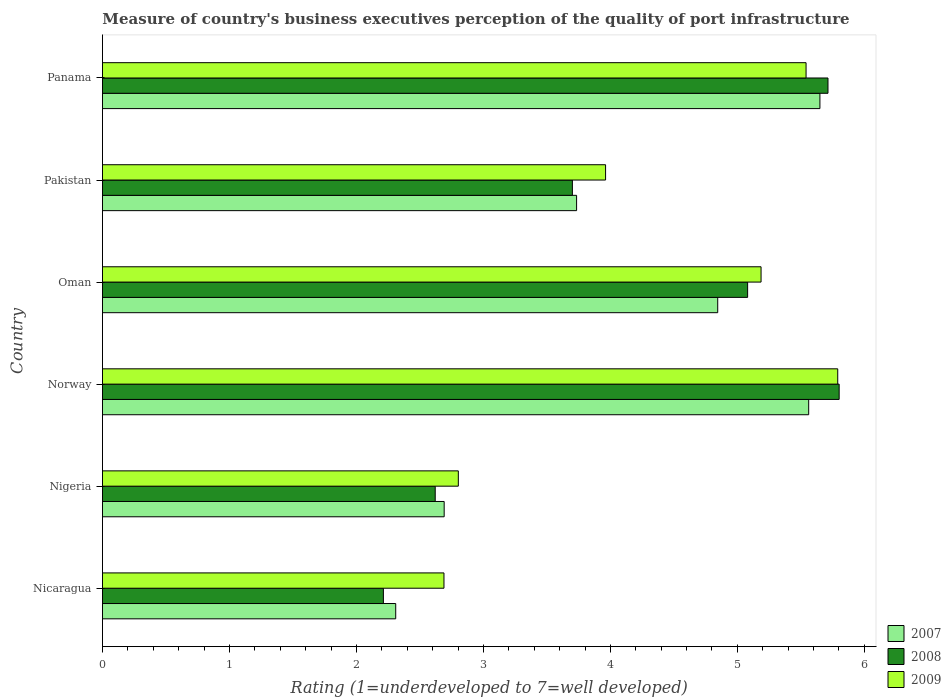How many different coloured bars are there?
Provide a short and direct response. 3. How many groups of bars are there?
Give a very brief answer. 6. Are the number of bars per tick equal to the number of legend labels?
Offer a terse response. Yes. Are the number of bars on each tick of the Y-axis equal?
Your answer should be compact. Yes. What is the label of the 2nd group of bars from the top?
Provide a succinct answer. Pakistan. In how many cases, is the number of bars for a given country not equal to the number of legend labels?
Provide a short and direct response. 0. What is the ratings of the quality of port infrastructure in 2009 in Nicaragua?
Ensure brevity in your answer.  2.69. Across all countries, what is the maximum ratings of the quality of port infrastructure in 2007?
Offer a very short reply. 5.65. Across all countries, what is the minimum ratings of the quality of port infrastructure in 2009?
Ensure brevity in your answer.  2.69. In which country was the ratings of the quality of port infrastructure in 2008 maximum?
Provide a succinct answer. Norway. In which country was the ratings of the quality of port infrastructure in 2008 minimum?
Provide a succinct answer. Nicaragua. What is the total ratings of the quality of port infrastructure in 2009 in the graph?
Your answer should be very brief. 25.97. What is the difference between the ratings of the quality of port infrastructure in 2008 in Nigeria and that in Oman?
Make the answer very short. -2.46. What is the difference between the ratings of the quality of port infrastructure in 2008 in Norway and the ratings of the quality of port infrastructure in 2007 in Oman?
Your response must be concise. 0.96. What is the average ratings of the quality of port infrastructure in 2007 per country?
Offer a very short reply. 4.13. What is the difference between the ratings of the quality of port infrastructure in 2008 and ratings of the quality of port infrastructure in 2007 in Pakistan?
Keep it short and to the point. -0.03. What is the ratio of the ratings of the quality of port infrastructure in 2008 in Pakistan to that in Panama?
Your answer should be very brief. 0.65. What is the difference between the highest and the second highest ratings of the quality of port infrastructure in 2008?
Provide a succinct answer. 0.09. What is the difference between the highest and the lowest ratings of the quality of port infrastructure in 2007?
Provide a succinct answer. 3.34. What does the 3rd bar from the bottom in Oman represents?
Your response must be concise. 2009. Is it the case that in every country, the sum of the ratings of the quality of port infrastructure in 2009 and ratings of the quality of port infrastructure in 2007 is greater than the ratings of the quality of port infrastructure in 2008?
Offer a very short reply. Yes. How many bars are there?
Give a very brief answer. 18. How many legend labels are there?
Offer a very short reply. 3. What is the title of the graph?
Your response must be concise. Measure of country's business executives perception of the quality of port infrastructure. What is the label or title of the X-axis?
Your answer should be very brief. Rating (1=underdeveloped to 7=well developed). What is the Rating (1=underdeveloped to 7=well developed) in 2007 in Nicaragua?
Keep it short and to the point. 2.31. What is the Rating (1=underdeveloped to 7=well developed) in 2008 in Nicaragua?
Your response must be concise. 2.21. What is the Rating (1=underdeveloped to 7=well developed) of 2009 in Nicaragua?
Your answer should be very brief. 2.69. What is the Rating (1=underdeveloped to 7=well developed) of 2007 in Nigeria?
Offer a terse response. 2.69. What is the Rating (1=underdeveloped to 7=well developed) in 2008 in Nigeria?
Keep it short and to the point. 2.62. What is the Rating (1=underdeveloped to 7=well developed) of 2009 in Nigeria?
Give a very brief answer. 2.8. What is the Rating (1=underdeveloped to 7=well developed) of 2007 in Norway?
Provide a short and direct response. 5.56. What is the Rating (1=underdeveloped to 7=well developed) in 2008 in Norway?
Make the answer very short. 5.8. What is the Rating (1=underdeveloped to 7=well developed) of 2009 in Norway?
Offer a very short reply. 5.79. What is the Rating (1=underdeveloped to 7=well developed) in 2007 in Oman?
Your answer should be compact. 4.85. What is the Rating (1=underdeveloped to 7=well developed) of 2008 in Oman?
Your answer should be very brief. 5.08. What is the Rating (1=underdeveloped to 7=well developed) in 2009 in Oman?
Your response must be concise. 5.19. What is the Rating (1=underdeveloped to 7=well developed) of 2007 in Pakistan?
Your answer should be compact. 3.73. What is the Rating (1=underdeveloped to 7=well developed) of 2008 in Pakistan?
Offer a terse response. 3.7. What is the Rating (1=underdeveloped to 7=well developed) of 2009 in Pakistan?
Your response must be concise. 3.96. What is the Rating (1=underdeveloped to 7=well developed) in 2007 in Panama?
Offer a terse response. 5.65. What is the Rating (1=underdeveloped to 7=well developed) of 2008 in Panama?
Keep it short and to the point. 5.71. What is the Rating (1=underdeveloped to 7=well developed) in 2009 in Panama?
Keep it short and to the point. 5.54. Across all countries, what is the maximum Rating (1=underdeveloped to 7=well developed) in 2007?
Keep it short and to the point. 5.65. Across all countries, what is the maximum Rating (1=underdeveloped to 7=well developed) of 2008?
Provide a short and direct response. 5.8. Across all countries, what is the maximum Rating (1=underdeveloped to 7=well developed) in 2009?
Offer a very short reply. 5.79. Across all countries, what is the minimum Rating (1=underdeveloped to 7=well developed) of 2007?
Your answer should be compact. 2.31. Across all countries, what is the minimum Rating (1=underdeveloped to 7=well developed) of 2008?
Your answer should be compact. 2.21. Across all countries, what is the minimum Rating (1=underdeveloped to 7=well developed) of 2009?
Offer a terse response. 2.69. What is the total Rating (1=underdeveloped to 7=well developed) in 2007 in the graph?
Ensure brevity in your answer.  24.79. What is the total Rating (1=underdeveloped to 7=well developed) of 2008 in the graph?
Give a very brief answer. 25.13. What is the total Rating (1=underdeveloped to 7=well developed) of 2009 in the graph?
Provide a short and direct response. 25.97. What is the difference between the Rating (1=underdeveloped to 7=well developed) in 2007 in Nicaragua and that in Nigeria?
Provide a short and direct response. -0.38. What is the difference between the Rating (1=underdeveloped to 7=well developed) in 2008 in Nicaragua and that in Nigeria?
Offer a very short reply. -0.41. What is the difference between the Rating (1=underdeveloped to 7=well developed) of 2009 in Nicaragua and that in Nigeria?
Your answer should be compact. -0.11. What is the difference between the Rating (1=underdeveloped to 7=well developed) of 2007 in Nicaragua and that in Norway?
Offer a very short reply. -3.25. What is the difference between the Rating (1=underdeveloped to 7=well developed) in 2008 in Nicaragua and that in Norway?
Offer a very short reply. -3.59. What is the difference between the Rating (1=underdeveloped to 7=well developed) of 2009 in Nicaragua and that in Norway?
Ensure brevity in your answer.  -3.1. What is the difference between the Rating (1=underdeveloped to 7=well developed) of 2007 in Nicaragua and that in Oman?
Your response must be concise. -2.54. What is the difference between the Rating (1=underdeveloped to 7=well developed) of 2008 in Nicaragua and that in Oman?
Keep it short and to the point. -2.87. What is the difference between the Rating (1=underdeveloped to 7=well developed) in 2009 in Nicaragua and that in Oman?
Keep it short and to the point. -2.5. What is the difference between the Rating (1=underdeveloped to 7=well developed) of 2007 in Nicaragua and that in Pakistan?
Your answer should be compact. -1.42. What is the difference between the Rating (1=underdeveloped to 7=well developed) of 2008 in Nicaragua and that in Pakistan?
Offer a terse response. -1.49. What is the difference between the Rating (1=underdeveloped to 7=well developed) in 2009 in Nicaragua and that in Pakistan?
Make the answer very short. -1.27. What is the difference between the Rating (1=underdeveloped to 7=well developed) in 2007 in Nicaragua and that in Panama?
Your response must be concise. -3.34. What is the difference between the Rating (1=underdeveloped to 7=well developed) in 2008 in Nicaragua and that in Panama?
Give a very brief answer. -3.5. What is the difference between the Rating (1=underdeveloped to 7=well developed) in 2009 in Nicaragua and that in Panama?
Give a very brief answer. -2.85. What is the difference between the Rating (1=underdeveloped to 7=well developed) of 2007 in Nigeria and that in Norway?
Give a very brief answer. -2.87. What is the difference between the Rating (1=underdeveloped to 7=well developed) of 2008 in Nigeria and that in Norway?
Provide a succinct answer. -3.18. What is the difference between the Rating (1=underdeveloped to 7=well developed) in 2009 in Nigeria and that in Norway?
Keep it short and to the point. -2.99. What is the difference between the Rating (1=underdeveloped to 7=well developed) of 2007 in Nigeria and that in Oman?
Your answer should be very brief. -2.15. What is the difference between the Rating (1=underdeveloped to 7=well developed) in 2008 in Nigeria and that in Oman?
Offer a terse response. -2.46. What is the difference between the Rating (1=underdeveloped to 7=well developed) in 2009 in Nigeria and that in Oman?
Your answer should be compact. -2.38. What is the difference between the Rating (1=underdeveloped to 7=well developed) of 2007 in Nigeria and that in Pakistan?
Provide a succinct answer. -1.04. What is the difference between the Rating (1=underdeveloped to 7=well developed) in 2008 in Nigeria and that in Pakistan?
Provide a short and direct response. -1.08. What is the difference between the Rating (1=underdeveloped to 7=well developed) in 2009 in Nigeria and that in Pakistan?
Make the answer very short. -1.16. What is the difference between the Rating (1=underdeveloped to 7=well developed) of 2007 in Nigeria and that in Panama?
Your answer should be very brief. -2.96. What is the difference between the Rating (1=underdeveloped to 7=well developed) in 2008 in Nigeria and that in Panama?
Your answer should be compact. -3.09. What is the difference between the Rating (1=underdeveloped to 7=well developed) in 2009 in Nigeria and that in Panama?
Offer a terse response. -2.74. What is the difference between the Rating (1=underdeveloped to 7=well developed) of 2007 in Norway and that in Oman?
Give a very brief answer. 0.72. What is the difference between the Rating (1=underdeveloped to 7=well developed) in 2008 in Norway and that in Oman?
Your answer should be compact. 0.72. What is the difference between the Rating (1=underdeveloped to 7=well developed) in 2009 in Norway and that in Oman?
Your answer should be very brief. 0.6. What is the difference between the Rating (1=underdeveloped to 7=well developed) of 2007 in Norway and that in Pakistan?
Ensure brevity in your answer.  1.83. What is the difference between the Rating (1=underdeveloped to 7=well developed) of 2008 in Norway and that in Pakistan?
Your answer should be very brief. 2.1. What is the difference between the Rating (1=underdeveloped to 7=well developed) of 2009 in Norway and that in Pakistan?
Ensure brevity in your answer.  1.83. What is the difference between the Rating (1=underdeveloped to 7=well developed) in 2007 in Norway and that in Panama?
Give a very brief answer. -0.09. What is the difference between the Rating (1=underdeveloped to 7=well developed) in 2008 in Norway and that in Panama?
Offer a terse response. 0.09. What is the difference between the Rating (1=underdeveloped to 7=well developed) in 2009 in Norway and that in Panama?
Offer a very short reply. 0.25. What is the difference between the Rating (1=underdeveloped to 7=well developed) in 2007 in Oman and that in Pakistan?
Give a very brief answer. 1.11. What is the difference between the Rating (1=underdeveloped to 7=well developed) in 2008 in Oman and that in Pakistan?
Ensure brevity in your answer.  1.38. What is the difference between the Rating (1=underdeveloped to 7=well developed) in 2009 in Oman and that in Pakistan?
Ensure brevity in your answer.  1.22. What is the difference between the Rating (1=underdeveloped to 7=well developed) in 2007 in Oman and that in Panama?
Keep it short and to the point. -0.8. What is the difference between the Rating (1=underdeveloped to 7=well developed) in 2008 in Oman and that in Panama?
Ensure brevity in your answer.  -0.63. What is the difference between the Rating (1=underdeveloped to 7=well developed) of 2009 in Oman and that in Panama?
Give a very brief answer. -0.35. What is the difference between the Rating (1=underdeveloped to 7=well developed) of 2007 in Pakistan and that in Panama?
Make the answer very short. -1.92. What is the difference between the Rating (1=underdeveloped to 7=well developed) in 2008 in Pakistan and that in Panama?
Give a very brief answer. -2.01. What is the difference between the Rating (1=underdeveloped to 7=well developed) of 2009 in Pakistan and that in Panama?
Offer a terse response. -1.58. What is the difference between the Rating (1=underdeveloped to 7=well developed) in 2007 in Nicaragua and the Rating (1=underdeveloped to 7=well developed) in 2008 in Nigeria?
Provide a succinct answer. -0.31. What is the difference between the Rating (1=underdeveloped to 7=well developed) of 2007 in Nicaragua and the Rating (1=underdeveloped to 7=well developed) of 2009 in Nigeria?
Provide a short and direct response. -0.49. What is the difference between the Rating (1=underdeveloped to 7=well developed) in 2008 in Nicaragua and the Rating (1=underdeveloped to 7=well developed) in 2009 in Nigeria?
Provide a short and direct response. -0.59. What is the difference between the Rating (1=underdeveloped to 7=well developed) in 2007 in Nicaragua and the Rating (1=underdeveloped to 7=well developed) in 2008 in Norway?
Offer a terse response. -3.49. What is the difference between the Rating (1=underdeveloped to 7=well developed) of 2007 in Nicaragua and the Rating (1=underdeveloped to 7=well developed) of 2009 in Norway?
Ensure brevity in your answer.  -3.48. What is the difference between the Rating (1=underdeveloped to 7=well developed) in 2008 in Nicaragua and the Rating (1=underdeveloped to 7=well developed) in 2009 in Norway?
Provide a succinct answer. -3.58. What is the difference between the Rating (1=underdeveloped to 7=well developed) of 2007 in Nicaragua and the Rating (1=underdeveloped to 7=well developed) of 2008 in Oman?
Give a very brief answer. -2.77. What is the difference between the Rating (1=underdeveloped to 7=well developed) in 2007 in Nicaragua and the Rating (1=underdeveloped to 7=well developed) in 2009 in Oman?
Your answer should be very brief. -2.88. What is the difference between the Rating (1=underdeveloped to 7=well developed) of 2008 in Nicaragua and the Rating (1=underdeveloped to 7=well developed) of 2009 in Oman?
Offer a very short reply. -2.97. What is the difference between the Rating (1=underdeveloped to 7=well developed) of 2007 in Nicaragua and the Rating (1=underdeveloped to 7=well developed) of 2008 in Pakistan?
Keep it short and to the point. -1.39. What is the difference between the Rating (1=underdeveloped to 7=well developed) of 2007 in Nicaragua and the Rating (1=underdeveloped to 7=well developed) of 2009 in Pakistan?
Ensure brevity in your answer.  -1.65. What is the difference between the Rating (1=underdeveloped to 7=well developed) in 2008 in Nicaragua and the Rating (1=underdeveloped to 7=well developed) in 2009 in Pakistan?
Make the answer very short. -1.75. What is the difference between the Rating (1=underdeveloped to 7=well developed) in 2007 in Nicaragua and the Rating (1=underdeveloped to 7=well developed) in 2008 in Panama?
Your answer should be very brief. -3.4. What is the difference between the Rating (1=underdeveloped to 7=well developed) in 2007 in Nicaragua and the Rating (1=underdeveloped to 7=well developed) in 2009 in Panama?
Provide a short and direct response. -3.23. What is the difference between the Rating (1=underdeveloped to 7=well developed) in 2008 in Nicaragua and the Rating (1=underdeveloped to 7=well developed) in 2009 in Panama?
Your response must be concise. -3.33. What is the difference between the Rating (1=underdeveloped to 7=well developed) in 2007 in Nigeria and the Rating (1=underdeveloped to 7=well developed) in 2008 in Norway?
Offer a terse response. -3.11. What is the difference between the Rating (1=underdeveloped to 7=well developed) in 2007 in Nigeria and the Rating (1=underdeveloped to 7=well developed) in 2009 in Norway?
Ensure brevity in your answer.  -3.1. What is the difference between the Rating (1=underdeveloped to 7=well developed) of 2008 in Nigeria and the Rating (1=underdeveloped to 7=well developed) of 2009 in Norway?
Offer a terse response. -3.17. What is the difference between the Rating (1=underdeveloped to 7=well developed) of 2007 in Nigeria and the Rating (1=underdeveloped to 7=well developed) of 2008 in Oman?
Make the answer very short. -2.39. What is the difference between the Rating (1=underdeveloped to 7=well developed) of 2007 in Nigeria and the Rating (1=underdeveloped to 7=well developed) of 2009 in Oman?
Offer a terse response. -2.5. What is the difference between the Rating (1=underdeveloped to 7=well developed) in 2008 in Nigeria and the Rating (1=underdeveloped to 7=well developed) in 2009 in Oman?
Keep it short and to the point. -2.57. What is the difference between the Rating (1=underdeveloped to 7=well developed) in 2007 in Nigeria and the Rating (1=underdeveloped to 7=well developed) in 2008 in Pakistan?
Give a very brief answer. -1.01. What is the difference between the Rating (1=underdeveloped to 7=well developed) in 2007 in Nigeria and the Rating (1=underdeveloped to 7=well developed) in 2009 in Pakistan?
Provide a succinct answer. -1.27. What is the difference between the Rating (1=underdeveloped to 7=well developed) of 2008 in Nigeria and the Rating (1=underdeveloped to 7=well developed) of 2009 in Pakistan?
Offer a very short reply. -1.34. What is the difference between the Rating (1=underdeveloped to 7=well developed) of 2007 in Nigeria and the Rating (1=underdeveloped to 7=well developed) of 2008 in Panama?
Your answer should be very brief. -3.02. What is the difference between the Rating (1=underdeveloped to 7=well developed) in 2007 in Nigeria and the Rating (1=underdeveloped to 7=well developed) in 2009 in Panama?
Give a very brief answer. -2.85. What is the difference between the Rating (1=underdeveloped to 7=well developed) in 2008 in Nigeria and the Rating (1=underdeveloped to 7=well developed) in 2009 in Panama?
Provide a short and direct response. -2.92. What is the difference between the Rating (1=underdeveloped to 7=well developed) of 2007 in Norway and the Rating (1=underdeveloped to 7=well developed) of 2008 in Oman?
Give a very brief answer. 0.48. What is the difference between the Rating (1=underdeveloped to 7=well developed) of 2007 in Norway and the Rating (1=underdeveloped to 7=well developed) of 2009 in Oman?
Make the answer very short. 0.38. What is the difference between the Rating (1=underdeveloped to 7=well developed) of 2008 in Norway and the Rating (1=underdeveloped to 7=well developed) of 2009 in Oman?
Keep it short and to the point. 0.62. What is the difference between the Rating (1=underdeveloped to 7=well developed) of 2007 in Norway and the Rating (1=underdeveloped to 7=well developed) of 2008 in Pakistan?
Your answer should be compact. 1.86. What is the difference between the Rating (1=underdeveloped to 7=well developed) of 2007 in Norway and the Rating (1=underdeveloped to 7=well developed) of 2009 in Pakistan?
Your answer should be very brief. 1.6. What is the difference between the Rating (1=underdeveloped to 7=well developed) in 2008 in Norway and the Rating (1=underdeveloped to 7=well developed) in 2009 in Pakistan?
Your answer should be compact. 1.84. What is the difference between the Rating (1=underdeveloped to 7=well developed) of 2007 in Norway and the Rating (1=underdeveloped to 7=well developed) of 2008 in Panama?
Your answer should be very brief. -0.15. What is the difference between the Rating (1=underdeveloped to 7=well developed) in 2007 in Norway and the Rating (1=underdeveloped to 7=well developed) in 2009 in Panama?
Give a very brief answer. 0.02. What is the difference between the Rating (1=underdeveloped to 7=well developed) in 2008 in Norway and the Rating (1=underdeveloped to 7=well developed) in 2009 in Panama?
Your answer should be compact. 0.26. What is the difference between the Rating (1=underdeveloped to 7=well developed) of 2007 in Oman and the Rating (1=underdeveloped to 7=well developed) of 2008 in Pakistan?
Make the answer very short. 1.14. What is the difference between the Rating (1=underdeveloped to 7=well developed) of 2007 in Oman and the Rating (1=underdeveloped to 7=well developed) of 2009 in Pakistan?
Ensure brevity in your answer.  0.88. What is the difference between the Rating (1=underdeveloped to 7=well developed) in 2008 in Oman and the Rating (1=underdeveloped to 7=well developed) in 2009 in Pakistan?
Keep it short and to the point. 1.12. What is the difference between the Rating (1=underdeveloped to 7=well developed) in 2007 in Oman and the Rating (1=underdeveloped to 7=well developed) in 2008 in Panama?
Provide a short and direct response. -0.87. What is the difference between the Rating (1=underdeveloped to 7=well developed) of 2007 in Oman and the Rating (1=underdeveloped to 7=well developed) of 2009 in Panama?
Ensure brevity in your answer.  -0.7. What is the difference between the Rating (1=underdeveloped to 7=well developed) of 2008 in Oman and the Rating (1=underdeveloped to 7=well developed) of 2009 in Panama?
Your answer should be very brief. -0.46. What is the difference between the Rating (1=underdeveloped to 7=well developed) in 2007 in Pakistan and the Rating (1=underdeveloped to 7=well developed) in 2008 in Panama?
Provide a short and direct response. -1.98. What is the difference between the Rating (1=underdeveloped to 7=well developed) of 2007 in Pakistan and the Rating (1=underdeveloped to 7=well developed) of 2009 in Panama?
Offer a terse response. -1.81. What is the difference between the Rating (1=underdeveloped to 7=well developed) in 2008 in Pakistan and the Rating (1=underdeveloped to 7=well developed) in 2009 in Panama?
Offer a very short reply. -1.84. What is the average Rating (1=underdeveloped to 7=well developed) in 2007 per country?
Make the answer very short. 4.13. What is the average Rating (1=underdeveloped to 7=well developed) in 2008 per country?
Provide a short and direct response. 4.19. What is the average Rating (1=underdeveloped to 7=well developed) of 2009 per country?
Provide a succinct answer. 4.33. What is the difference between the Rating (1=underdeveloped to 7=well developed) in 2007 and Rating (1=underdeveloped to 7=well developed) in 2008 in Nicaragua?
Offer a terse response. 0.1. What is the difference between the Rating (1=underdeveloped to 7=well developed) in 2007 and Rating (1=underdeveloped to 7=well developed) in 2009 in Nicaragua?
Provide a short and direct response. -0.38. What is the difference between the Rating (1=underdeveloped to 7=well developed) in 2008 and Rating (1=underdeveloped to 7=well developed) in 2009 in Nicaragua?
Ensure brevity in your answer.  -0.48. What is the difference between the Rating (1=underdeveloped to 7=well developed) of 2007 and Rating (1=underdeveloped to 7=well developed) of 2008 in Nigeria?
Your answer should be compact. 0.07. What is the difference between the Rating (1=underdeveloped to 7=well developed) in 2007 and Rating (1=underdeveloped to 7=well developed) in 2009 in Nigeria?
Give a very brief answer. -0.11. What is the difference between the Rating (1=underdeveloped to 7=well developed) in 2008 and Rating (1=underdeveloped to 7=well developed) in 2009 in Nigeria?
Your answer should be very brief. -0.18. What is the difference between the Rating (1=underdeveloped to 7=well developed) of 2007 and Rating (1=underdeveloped to 7=well developed) of 2008 in Norway?
Make the answer very short. -0.24. What is the difference between the Rating (1=underdeveloped to 7=well developed) in 2007 and Rating (1=underdeveloped to 7=well developed) in 2009 in Norway?
Your response must be concise. -0.23. What is the difference between the Rating (1=underdeveloped to 7=well developed) in 2008 and Rating (1=underdeveloped to 7=well developed) in 2009 in Norway?
Ensure brevity in your answer.  0.01. What is the difference between the Rating (1=underdeveloped to 7=well developed) in 2007 and Rating (1=underdeveloped to 7=well developed) in 2008 in Oman?
Your answer should be compact. -0.24. What is the difference between the Rating (1=underdeveloped to 7=well developed) of 2007 and Rating (1=underdeveloped to 7=well developed) of 2009 in Oman?
Your answer should be very brief. -0.34. What is the difference between the Rating (1=underdeveloped to 7=well developed) in 2008 and Rating (1=underdeveloped to 7=well developed) in 2009 in Oman?
Provide a short and direct response. -0.11. What is the difference between the Rating (1=underdeveloped to 7=well developed) in 2007 and Rating (1=underdeveloped to 7=well developed) in 2008 in Pakistan?
Offer a terse response. 0.03. What is the difference between the Rating (1=underdeveloped to 7=well developed) in 2007 and Rating (1=underdeveloped to 7=well developed) in 2009 in Pakistan?
Make the answer very short. -0.23. What is the difference between the Rating (1=underdeveloped to 7=well developed) of 2008 and Rating (1=underdeveloped to 7=well developed) of 2009 in Pakistan?
Keep it short and to the point. -0.26. What is the difference between the Rating (1=underdeveloped to 7=well developed) of 2007 and Rating (1=underdeveloped to 7=well developed) of 2008 in Panama?
Your response must be concise. -0.06. What is the difference between the Rating (1=underdeveloped to 7=well developed) in 2007 and Rating (1=underdeveloped to 7=well developed) in 2009 in Panama?
Provide a short and direct response. 0.11. What is the difference between the Rating (1=underdeveloped to 7=well developed) in 2008 and Rating (1=underdeveloped to 7=well developed) in 2009 in Panama?
Offer a terse response. 0.17. What is the ratio of the Rating (1=underdeveloped to 7=well developed) in 2007 in Nicaragua to that in Nigeria?
Offer a terse response. 0.86. What is the ratio of the Rating (1=underdeveloped to 7=well developed) in 2008 in Nicaragua to that in Nigeria?
Offer a very short reply. 0.84. What is the ratio of the Rating (1=underdeveloped to 7=well developed) of 2009 in Nicaragua to that in Nigeria?
Provide a short and direct response. 0.96. What is the ratio of the Rating (1=underdeveloped to 7=well developed) of 2007 in Nicaragua to that in Norway?
Keep it short and to the point. 0.42. What is the ratio of the Rating (1=underdeveloped to 7=well developed) in 2008 in Nicaragua to that in Norway?
Provide a succinct answer. 0.38. What is the ratio of the Rating (1=underdeveloped to 7=well developed) of 2009 in Nicaragua to that in Norway?
Provide a short and direct response. 0.46. What is the ratio of the Rating (1=underdeveloped to 7=well developed) in 2007 in Nicaragua to that in Oman?
Offer a very short reply. 0.48. What is the ratio of the Rating (1=underdeveloped to 7=well developed) in 2008 in Nicaragua to that in Oman?
Provide a succinct answer. 0.44. What is the ratio of the Rating (1=underdeveloped to 7=well developed) in 2009 in Nicaragua to that in Oman?
Provide a short and direct response. 0.52. What is the ratio of the Rating (1=underdeveloped to 7=well developed) of 2007 in Nicaragua to that in Pakistan?
Provide a succinct answer. 0.62. What is the ratio of the Rating (1=underdeveloped to 7=well developed) in 2008 in Nicaragua to that in Pakistan?
Offer a very short reply. 0.6. What is the ratio of the Rating (1=underdeveloped to 7=well developed) of 2009 in Nicaragua to that in Pakistan?
Provide a short and direct response. 0.68. What is the ratio of the Rating (1=underdeveloped to 7=well developed) of 2007 in Nicaragua to that in Panama?
Your answer should be compact. 0.41. What is the ratio of the Rating (1=underdeveloped to 7=well developed) of 2008 in Nicaragua to that in Panama?
Offer a terse response. 0.39. What is the ratio of the Rating (1=underdeveloped to 7=well developed) in 2009 in Nicaragua to that in Panama?
Your answer should be very brief. 0.49. What is the ratio of the Rating (1=underdeveloped to 7=well developed) in 2007 in Nigeria to that in Norway?
Make the answer very short. 0.48. What is the ratio of the Rating (1=underdeveloped to 7=well developed) in 2008 in Nigeria to that in Norway?
Give a very brief answer. 0.45. What is the ratio of the Rating (1=underdeveloped to 7=well developed) of 2009 in Nigeria to that in Norway?
Offer a very short reply. 0.48. What is the ratio of the Rating (1=underdeveloped to 7=well developed) of 2007 in Nigeria to that in Oman?
Provide a short and direct response. 0.56. What is the ratio of the Rating (1=underdeveloped to 7=well developed) in 2008 in Nigeria to that in Oman?
Ensure brevity in your answer.  0.52. What is the ratio of the Rating (1=underdeveloped to 7=well developed) of 2009 in Nigeria to that in Oman?
Keep it short and to the point. 0.54. What is the ratio of the Rating (1=underdeveloped to 7=well developed) of 2007 in Nigeria to that in Pakistan?
Your answer should be very brief. 0.72. What is the ratio of the Rating (1=underdeveloped to 7=well developed) of 2008 in Nigeria to that in Pakistan?
Make the answer very short. 0.71. What is the ratio of the Rating (1=underdeveloped to 7=well developed) of 2009 in Nigeria to that in Pakistan?
Your answer should be very brief. 0.71. What is the ratio of the Rating (1=underdeveloped to 7=well developed) in 2007 in Nigeria to that in Panama?
Offer a terse response. 0.48. What is the ratio of the Rating (1=underdeveloped to 7=well developed) in 2008 in Nigeria to that in Panama?
Give a very brief answer. 0.46. What is the ratio of the Rating (1=underdeveloped to 7=well developed) in 2009 in Nigeria to that in Panama?
Provide a succinct answer. 0.51. What is the ratio of the Rating (1=underdeveloped to 7=well developed) in 2007 in Norway to that in Oman?
Keep it short and to the point. 1.15. What is the ratio of the Rating (1=underdeveloped to 7=well developed) of 2008 in Norway to that in Oman?
Your response must be concise. 1.14. What is the ratio of the Rating (1=underdeveloped to 7=well developed) of 2009 in Norway to that in Oman?
Give a very brief answer. 1.12. What is the ratio of the Rating (1=underdeveloped to 7=well developed) in 2007 in Norway to that in Pakistan?
Make the answer very short. 1.49. What is the ratio of the Rating (1=underdeveloped to 7=well developed) in 2008 in Norway to that in Pakistan?
Offer a terse response. 1.57. What is the ratio of the Rating (1=underdeveloped to 7=well developed) of 2009 in Norway to that in Pakistan?
Keep it short and to the point. 1.46. What is the ratio of the Rating (1=underdeveloped to 7=well developed) of 2007 in Norway to that in Panama?
Your response must be concise. 0.98. What is the ratio of the Rating (1=underdeveloped to 7=well developed) in 2008 in Norway to that in Panama?
Offer a terse response. 1.02. What is the ratio of the Rating (1=underdeveloped to 7=well developed) in 2009 in Norway to that in Panama?
Your answer should be very brief. 1.04. What is the ratio of the Rating (1=underdeveloped to 7=well developed) in 2007 in Oman to that in Pakistan?
Keep it short and to the point. 1.3. What is the ratio of the Rating (1=underdeveloped to 7=well developed) of 2008 in Oman to that in Pakistan?
Keep it short and to the point. 1.37. What is the ratio of the Rating (1=underdeveloped to 7=well developed) in 2009 in Oman to that in Pakistan?
Offer a very short reply. 1.31. What is the ratio of the Rating (1=underdeveloped to 7=well developed) in 2007 in Oman to that in Panama?
Ensure brevity in your answer.  0.86. What is the ratio of the Rating (1=underdeveloped to 7=well developed) in 2008 in Oman to that in Panama?
Your answer should be compact. 0.89. What is the ratio of the Rating (1=underdeveloped to 7=well developed) in 2009 in Oman to that in Panama?
Provide a short and direct response. 0.94. What is the ratio of the Rating (1=underdeveloped to 7=well developed) in 2007 in Pakistan to that in Panama?
Provide a succinct answer. 0.66. What is the ratio of the Rating (1=underdeveloped to 7=well developed) in 2008 in Pakistan to that in Panama?
Offer a terse response. 0.65. What is the ratio of the Rating (1=underdeveloped to 7=well developed) in 2009 in Pakistan to that in Panama?
Provide a short and direct response. 0.72. What is the difference between the highest and the second highest Rating (1=underdeveloped to 7=well developed) in 2007?
Your answer should be compact. 0.09. What is the difference between the highest and the second highest Rating (1=underdeveloped to 7=well developed) in 2008?
Provide a succinct answer. 0.09. What is the difference between the highest and the second highest Rating (1=underdeveloped to 7=well developed) in 2009?
Provide a succinct answer. 0.25. What is the difference between the highest and the lowest Rating (1=underdeveloped to 7=well developed) of 2007?
Ensure brevity in your answer.  3.34. What is the difference between the highest and the lowest Rating (1=underdeveloped to 7=well developed) of 2008?
Provide a succinct answer. 3.59. What is the difference between the highest and the lowest Rating (1=underdeveloped to 7=well developed) in 2009?
Offer a very short reply. 3.1. 